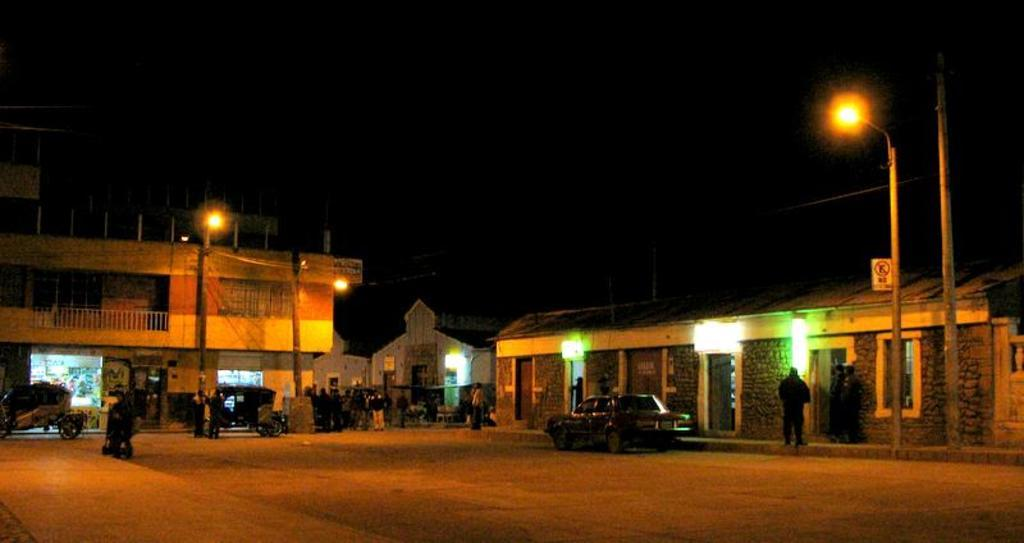How many people are in the image? There is a group of people in the image, but the exact number is not specified. What else can be seen in the image besides the people? There are vehicles, poles, lights, and buildings in the image. What might the poles be used for in the image? The poles could be used for supporting lights or other structures in the image. What type of structures are visible in the image? There are buildings in the image. What type of ground can be seen in the image? There is no specific information about the ground in the image. 